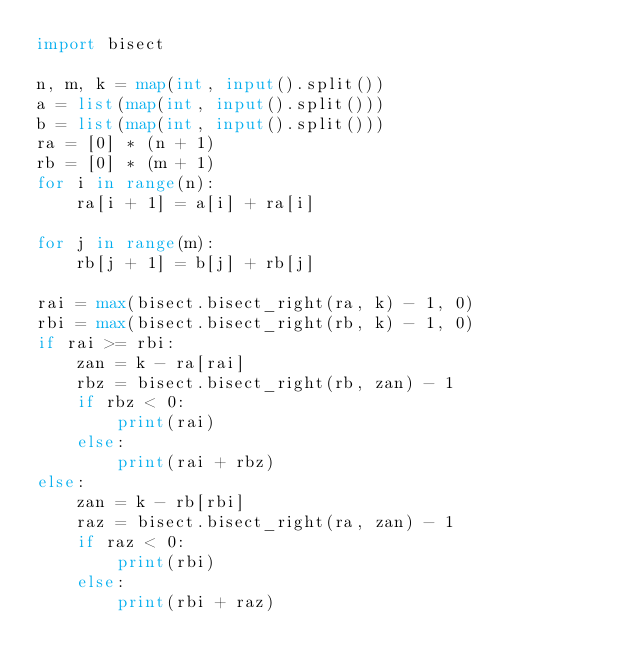Convert code to text. <code><loc_0><loc_0><loc_500><loc_500><_Python_>import bisect

n, m, k = map(int, input().split())
a = list(map(int, input().split()))
b = list(map(int, input().split()))
ra = [0] * (n + 1)
rb = [0] * (m + 1)
for i in range(n):
    ra[i + 1] = a[i] + ra[i]

for j in range(m):
    rb[j + 1] = b[j] + rb[j]

rai = max(bisect.bisect_right(ra, k) - 1, 0)
rbi = max(bisect.bisect_right(rb, k) - 1, 0)
if rai >= rbi:
    zan = k - ra[rai]
    rbz = bisect.bisect_right(rb, zan) - 1
    if rbz < 0:
        print(rai)
    else:
        print(rai + rbz)
else:
    zan = k - rb[rbi]
    raz = bisect.bisect_right(ra, zan) - 1
    if raz < 0:
        print(rbi)
    else:
        print(rbi + raz)
</code> 